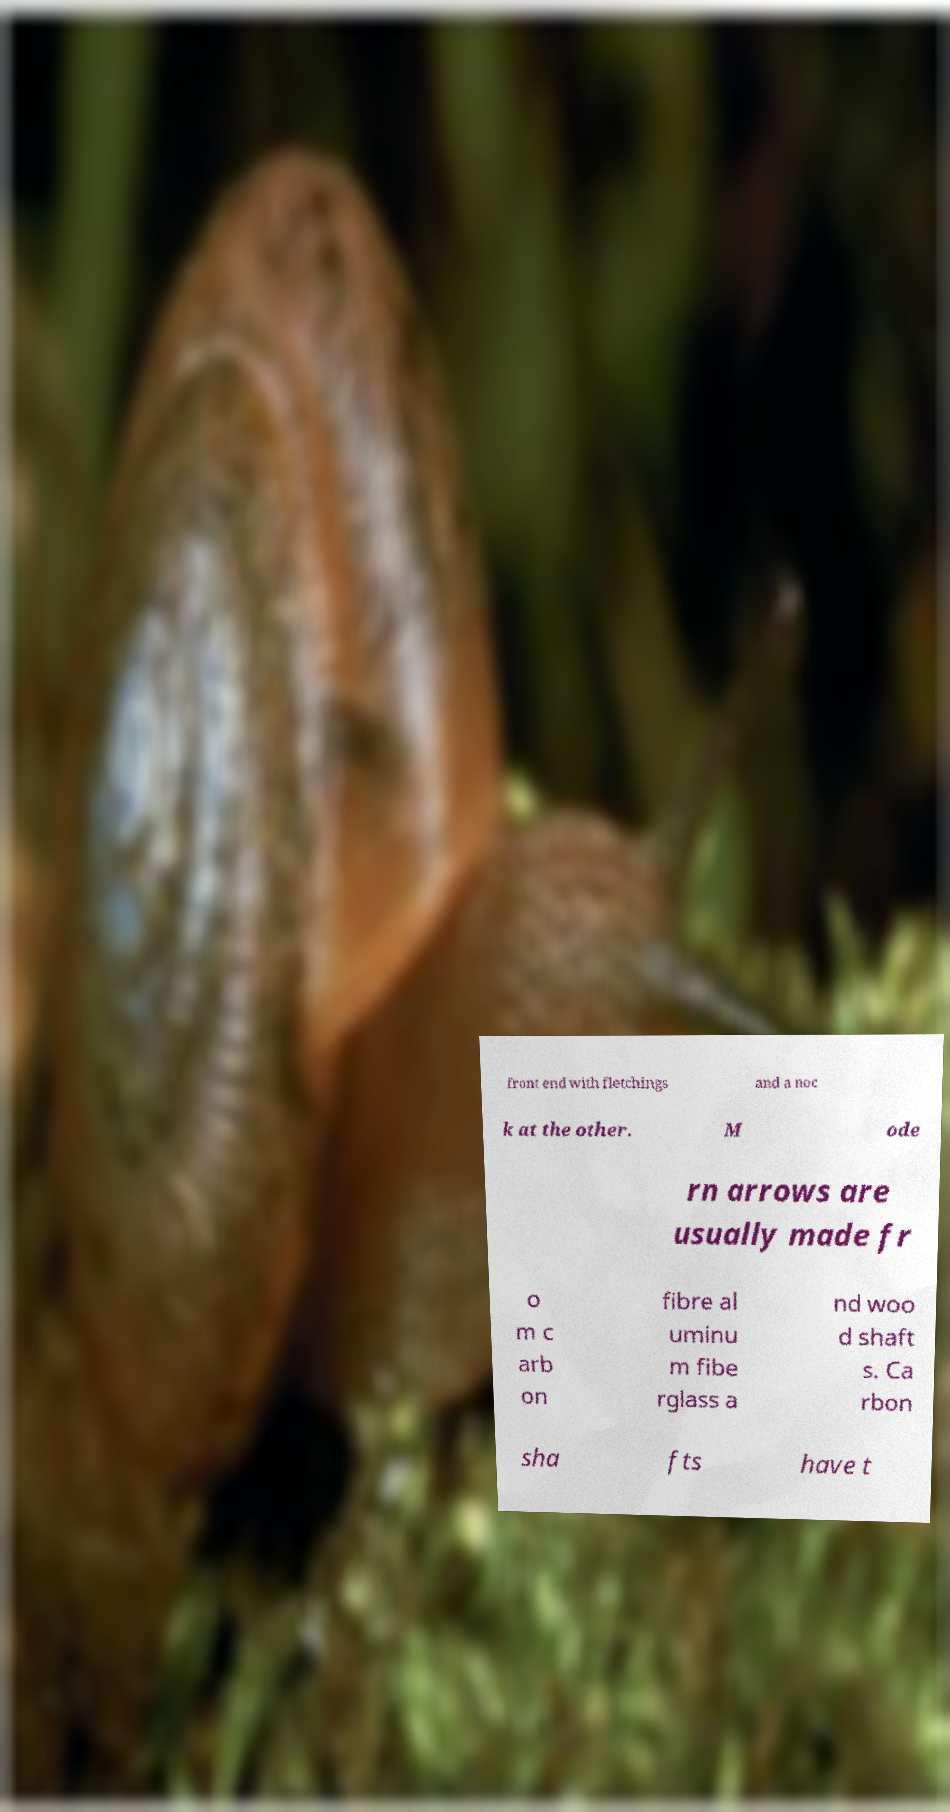There's text embedded in this image that I need extracted. Can you transcribe it verbatim? front end with fletchings and a noc k at the other. M ode rn arrows are usually made fr o m c arb on fibre al uminu m fibe rglass a nd woo d shaft s. Ca rbon sha fts have t 